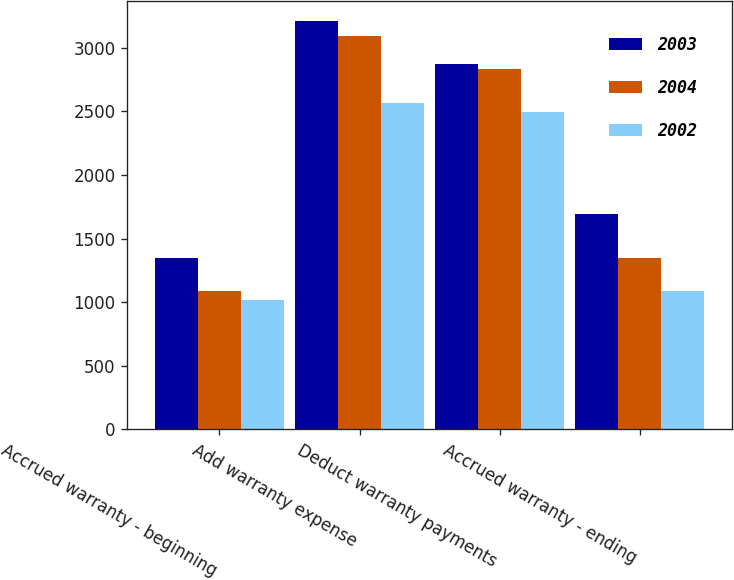Convert chart to OTSL. <chart><loc_0><loc_0><loc_500><loc_500><stacked_bar_chart><ecel><fcel>Accrued warranty - beginning<fcel>Add warranty expense<fcel>Deduct warranty payments<fcel>Accrued warranty - ending<nl><fcel>2003<fcel>1351<fcel>3209<fcel>2869<fcel>1691<nl><fcel>2004<fcel>1090<fcel>3095<fcel>2834<fcel>1351<nl><fcel>2002<fcel>1021<fcel>2564<fcel>2495<fcel>1090<nl></chart> 